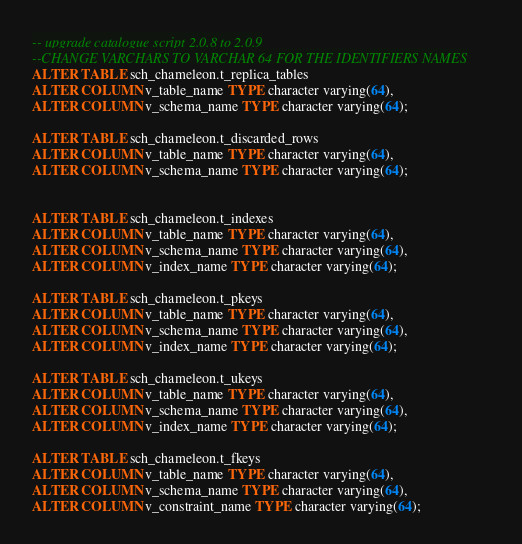<code> <loc_0><loc_0><loc_500><loc_500><_SQL_>-- upgrade catalogue script 2.0.8 to 2.0.9
--CHANGE VARCHARS TO VARCHAR 64 FOR THE IDENTIFIERS NAMES
ALTER TABLE sch_chameleon.t_replica_tables
ALTER COLUMN v_table_name TYPE character varying(64),
ALTER COLUMN v_schema_name TYPE character varying(64);

ALTER TABLE sch_chameleon.t_discarded_rows
ALTER COLUMN v_table_name TYPE character varying(64),
ALTER COLUMN v_schema_name TYPE character varying(64);


ALTER TABLE sch_chameleon.t_indexes
ALTER COLUMN v_table_name TYPE character varying(64),
ALTER COLUMN v_schema_name TYPE character varying(64), 
ALTER COLUMN v_index_name TYPE character varying(64);

ALTER TABLE sch_chameleon.t_pkeys
ALTER COLUMN v_table_name TYPE character varying(64),
ALTER COLUMN v_schema_name TYPE character varying(64), 
ALTER COLUMN v_index_name TYPE character varying(64);

ALTER TABLE sch_chameleon.t_ukeys
ALTER COLUMN v_table_name TYPE character varying(64),
ALTER COLUMN v_schema_name TYPE character varying(64), 
ALTER COLUMN v_index_name TYPE character varying(64);

ALTER TABLE sch_chameleon.t_fkeys
ALTER COLUMN v_table_name TYPE character varying(64),
ALTER COLUMN v_schema_name TYPE character varying(64), 
ALTER COLUMN v_constraint_name TYPE character varying(64);</code> 